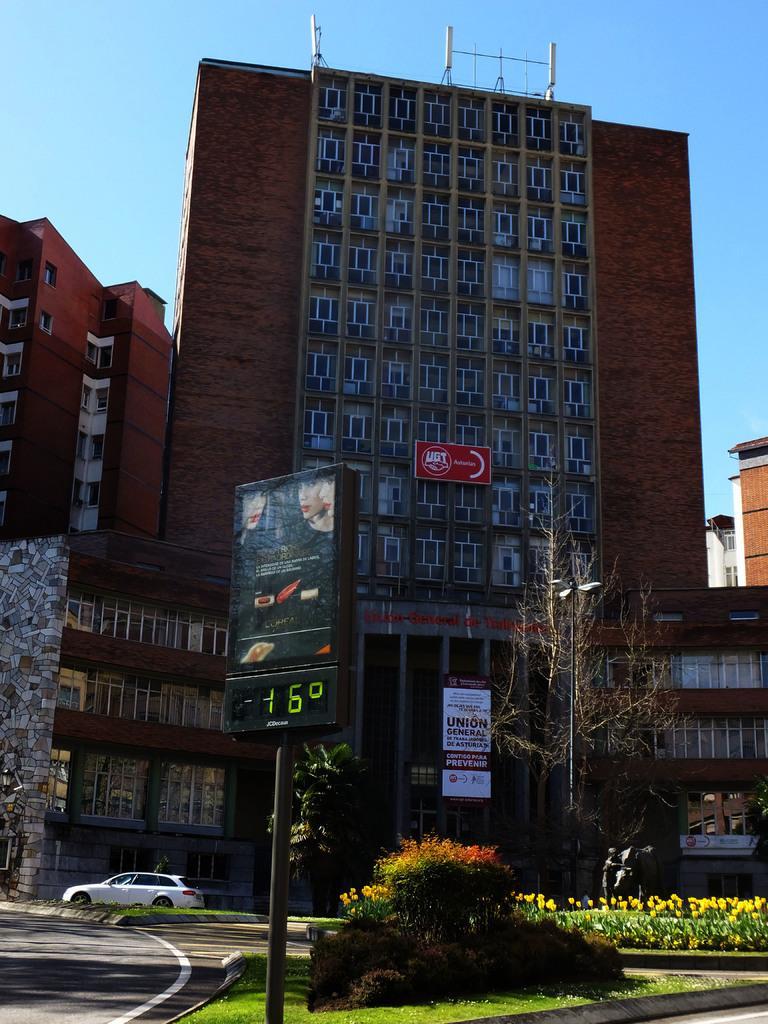In one or two sentences, can you explain what this image depicts? In this image we can see a road and a car on the left side. There is a board with a pole. Also there is grass and there are plants. In the back there is a tree and light pole. In the background there are buildings with windows. Also there are boards. And there is sky. 